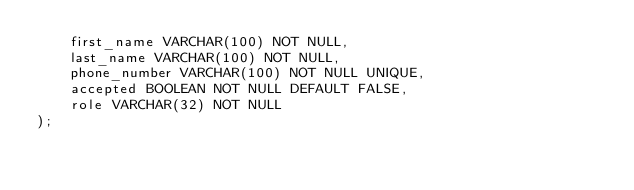Convert code to text. <code><loc_0><loc_0><loc_500><loc_500><_SQL_>    first_name VARCHAR(100) NOT NULL,
    last_name VARCHAR(100) NOT NULL,
    phone_number VARCHAR(100) NOT NULL UNIQUE,
    accepted BOOLEAN NOT NULL DEFAULT FALSE,
    role VARCHAR(32) NOT NULL
);
</code> 